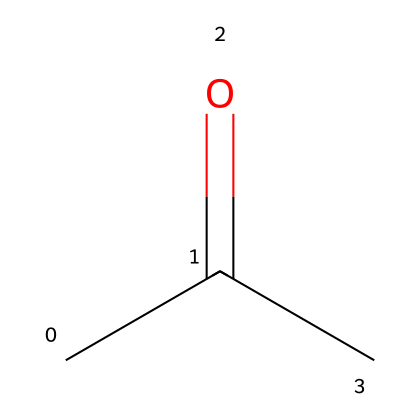What is the molecular formula of this compound? The provided SMILES representation "CC(=O)C" indicates that there are three carbon atoms (C) in total, along with six hydrogen atoms (H) and one oxygen atom (O), leading to the molecular formula C3H6O.
Answer: C3H6O How many hydrogen atoms are present in the molecule? Analyzing the SMILES "CC(=O)C", it can be inferred that there are six hydrogen atoms attached to the three carbon atoms indicated, leading to a total of six hydrogen atoms.
Answer: 6 What type of functional group is present in acetone? The structure includes a carbonyl group (C=O) indicated by the "C(=O)" portion of the SMILES, which is characteristic of ketones. Therefore, acetone contains a ketone functional group.
Answer: ketone Is acetone a polar molecule? The presence of the polar carbonyl group (C=O) contributes to the overall polarity of the molecule, making acetone a polar solvent.
Answer: yes What is the primary use of acetone in laboratories? Acetone is commonly used as a solvent to dissolve and remove various substances, including thermal paste, due to its ability to effectively break down non-polar and some polar compounds.
Answer: solvent 